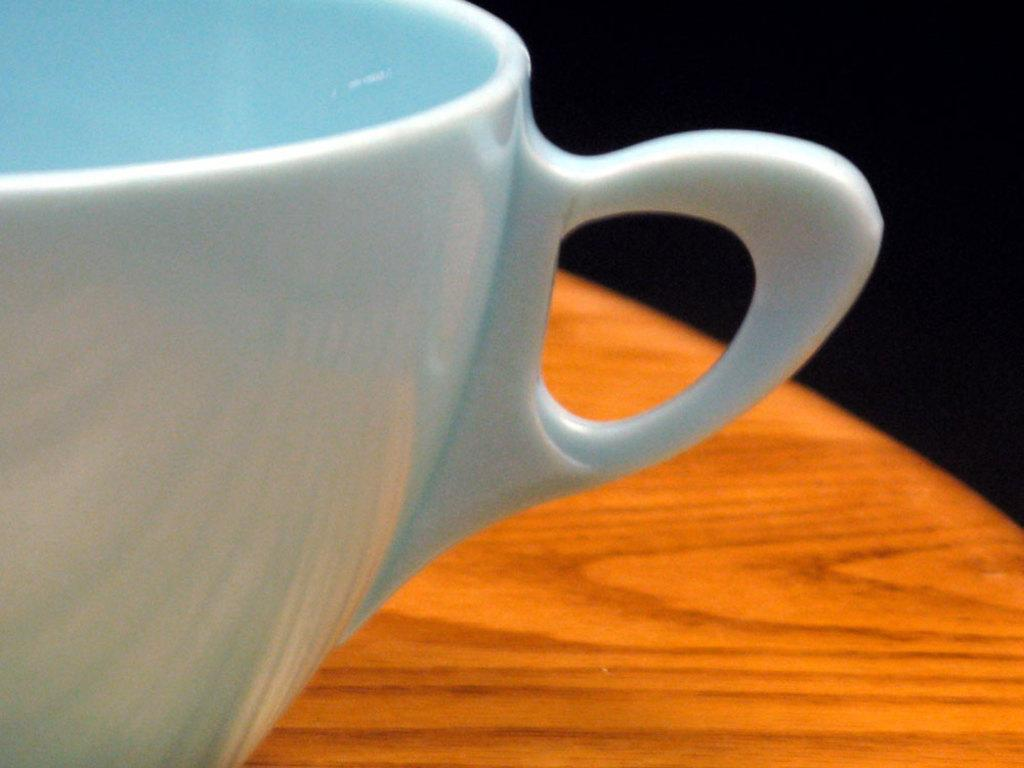What object is visible in the image? There is a cup in the image. Where is the cup located? The cup is on a table. What can be observed about the background of the image? The background of the image is dark. What type of stocking is hanging from the cup in the image? There is no stocking present in the image; it only features a cup on a table with a dark background. 